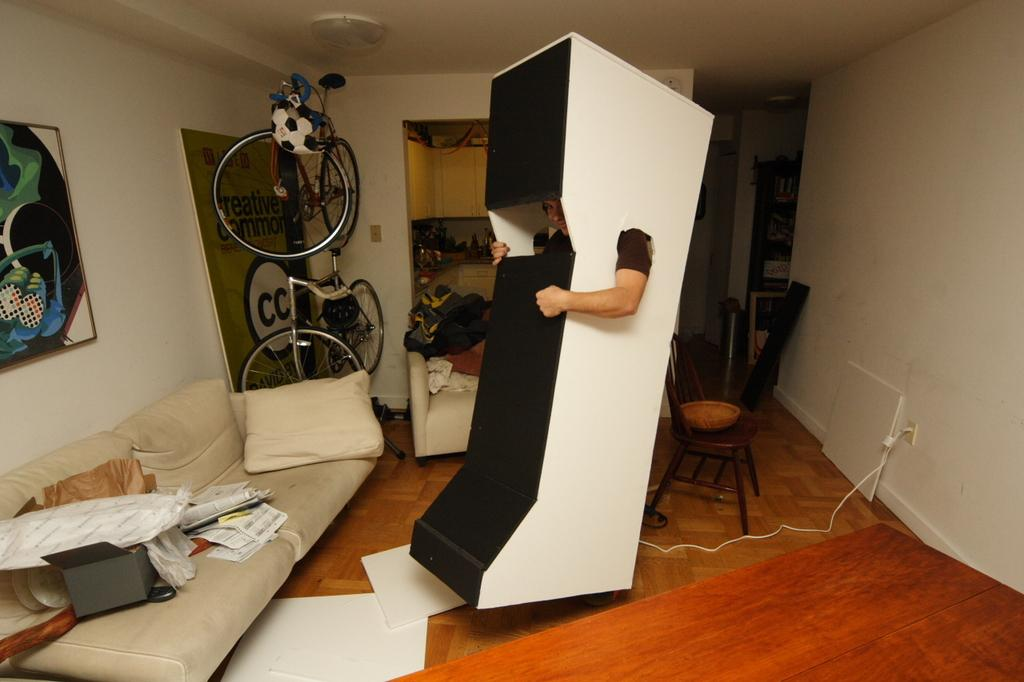What type of space is depicted in the image? There is a room in the image. What objects can be seen in the room? There is a cycle and a sofa in the room. What is the person in the room wearing? The person is wearing a costume that resembles a box. What type of treatment is being administered to the person in the room? There is no indication of any treatment being administered in the image. The person is simply wearing a costume that resembles a box. 